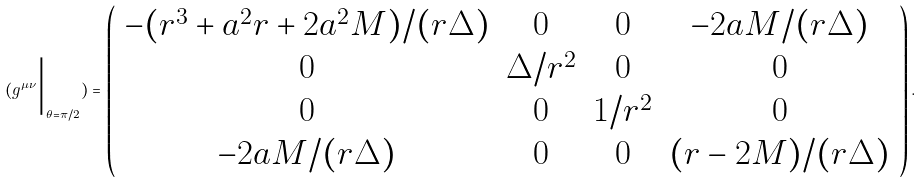<formula> <loc_0><loc_0><loc_500><loc_500>\, ( g ^ { \mu \nu } \Big | _ { \theta = \pi / 2 } ) = \left ( \begin{array} { c c c c } - ( r ^ { 3 } + a ^ { 2 } r + 2 a ^ { 2 } M ) / ( r \Delta ) & 0 & 0 & - 2 a M / ( r \Delta ) \\ 0 & \Delta / r ^ { 2 } & 0 & 0 \\ 0 & 0 & 1 / r ^ { 2 } & 0 \\ - 2 a M / ( r \Delta ) & 0 & 0 & ( r - 2 M ) / ( r \Delta ) \\ \end{array} \right ) .</formula> 